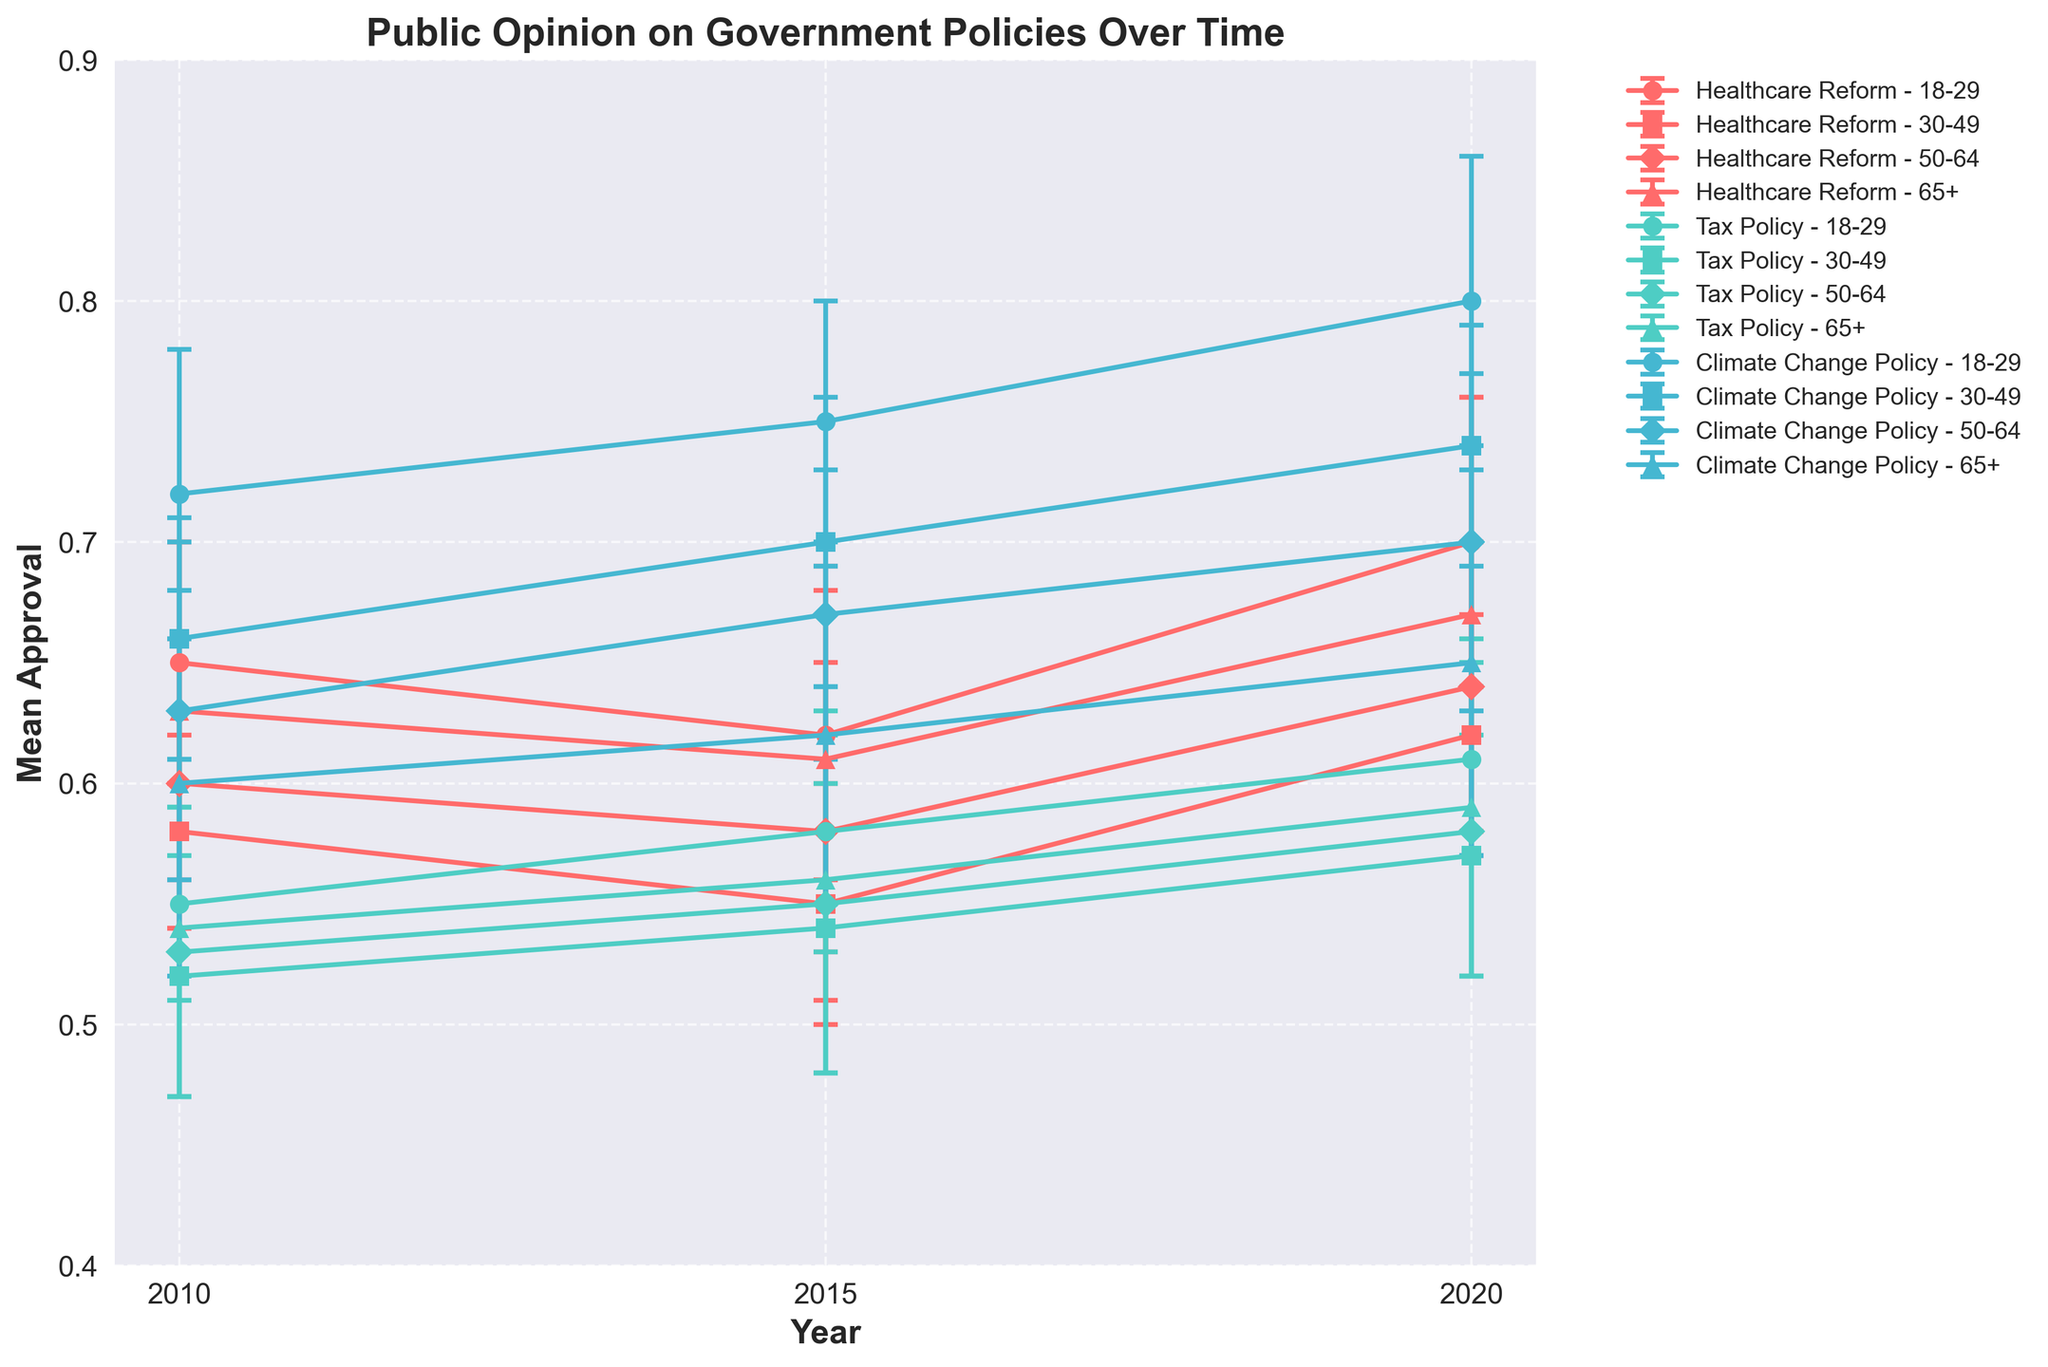What year had the highest approval rating for Healthcare Reform among the 18-29 demographic? The line representing the 18-29 demographic for Healthcare Reform reaches its highest point in 2020.
Answer: 2020 Which demographic group had the lowest mean approval for Tax Policy in 2015? In 2015, the demographic with the lowest approval rating for Tax Policy is the 30-49 group.
Answer: 30-49 Over the decade from 2010 to 2020, how did the mean approval rating for Climate Change Policy change among the 65+ demographic? The approval rating starts at around 0.60 in 2010, increases slightly to 0.62 in 2015, and reaches around 0.65 in 2020. The overall change is a gradual increase.
Answer: Gradual increase For Healthcare Reform in 2020, how do the error bars (representing the ApprovalStdDev) of the 65+ demographic compare to those of the 30-49 demographic? The error bars for the 65+ demographic are larger than those of the 30-49 demographic, indicating more variability in the approval rating.
Answer: 65+ has larger error bars What is the trend in the mean approval rating for the 18-29 demographic across all three policies from 2010 to 2020? For Healthcare Reform: slight dip in 2015 and then an increase by 2020. For Tax Policy: steady increase. For Climate Change Policy: consistent increase.
Answer: Healthcare Reform: slight dip and increase, Tax Policy: steady increase, Climate Change Policy: consistent increase In 2010, which policy had the highest mean approval rating for the 50-64 age group? The highest mean approval rating for the 50-64 age group in 2010 is for Climate Change Policy at around 0.63.
Answer: Climate Change Policy Compare the mean approval ratings and their corresponding error margins for Healthcare Reform in 2010 and 2020 for the demographic 50-64. In 2010, the mean approval is 0.60 with an error margin of 0.06. In 2020, the mean approval is 0.64 with an error margin of 0.06. The mean approval increases, while the error margin stays the same.
Answer: Increased mean with same error margin 